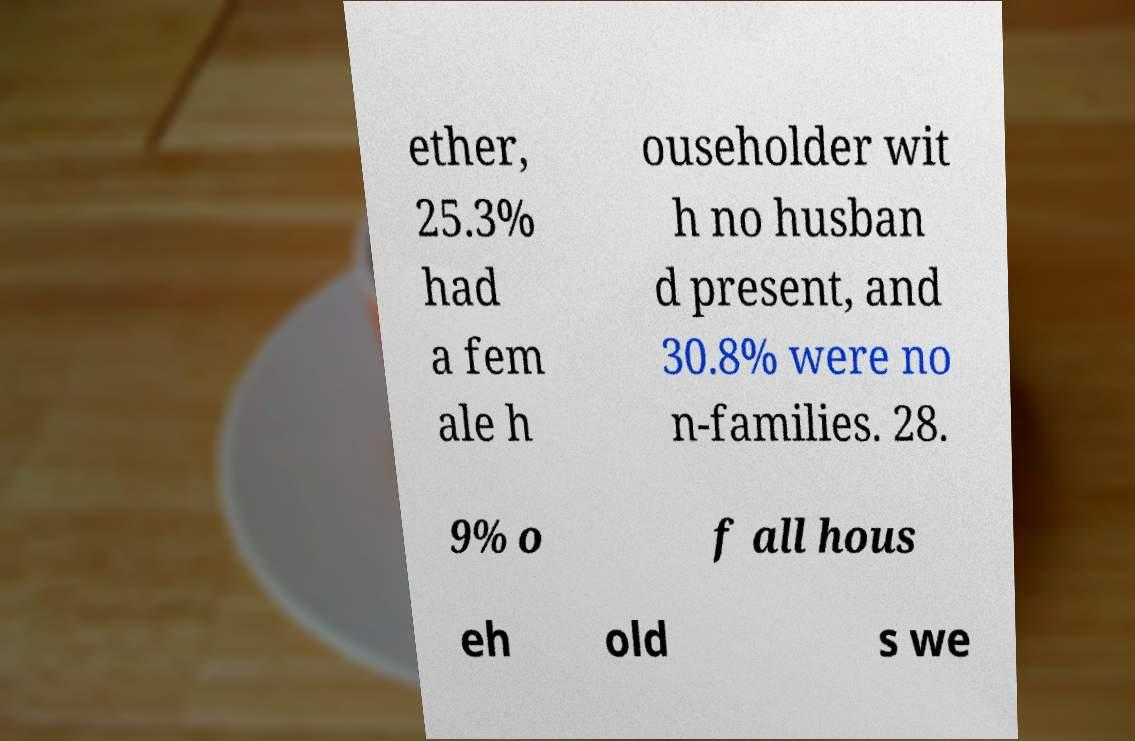There's text embedded in this image that I need extracted. Can you transcribe it verbatim? ether, 25.3% had a fem ale h ouseholder wit h no husban d present, and 30.8% were no n-families. 28. 9% o f all hous eh old s we 